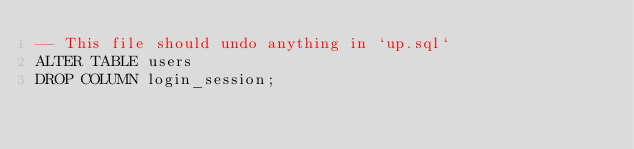<code> <loc_0><loc_0><loc_500><loc_500><_SQL_>-- This file should undo anything in `up.sql`
ALTER TABLE users
DROP COLUMN login_session;</code> 